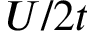Convert formula to latex. <formula><loc_0><loc_0><loc_500><loc_500>U / 2 t</formula> 